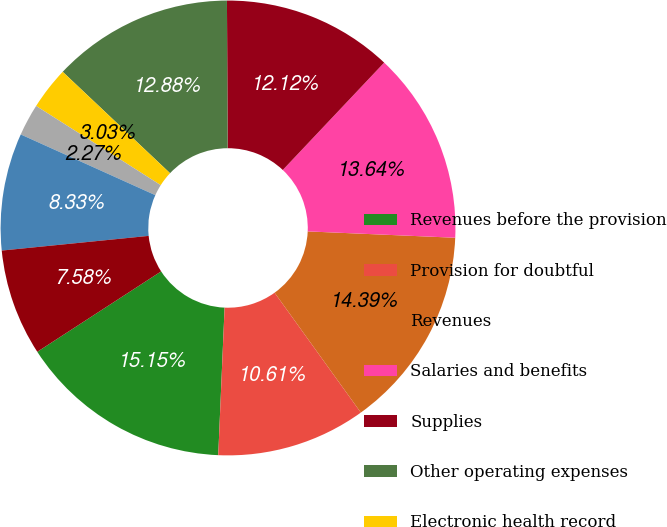Convert chart to OTSL. <chart><loc_0><loc_0><loc_500><loc_500><pie_chart><fcel>Revenues before the provision<fcel>Provision for doubtful<fcel>Revenues<fcel>Salaries and benefits<fcel>Supplies<fcel>Other operating expenses<fcel>Electronic health record<fcel>Equity in earnings of<fcel>Depreciation and amortization<fcel>Interest expense<nl><fcel>15.15%<fcel>10.61%<fcel>14.39%<fcel>13.64%<fcel>12.12%<fcel>12.88%<fcel>3.03%<fcel>2.27%<fcel>8.33%<fcel>7.58%<nl></chart> 